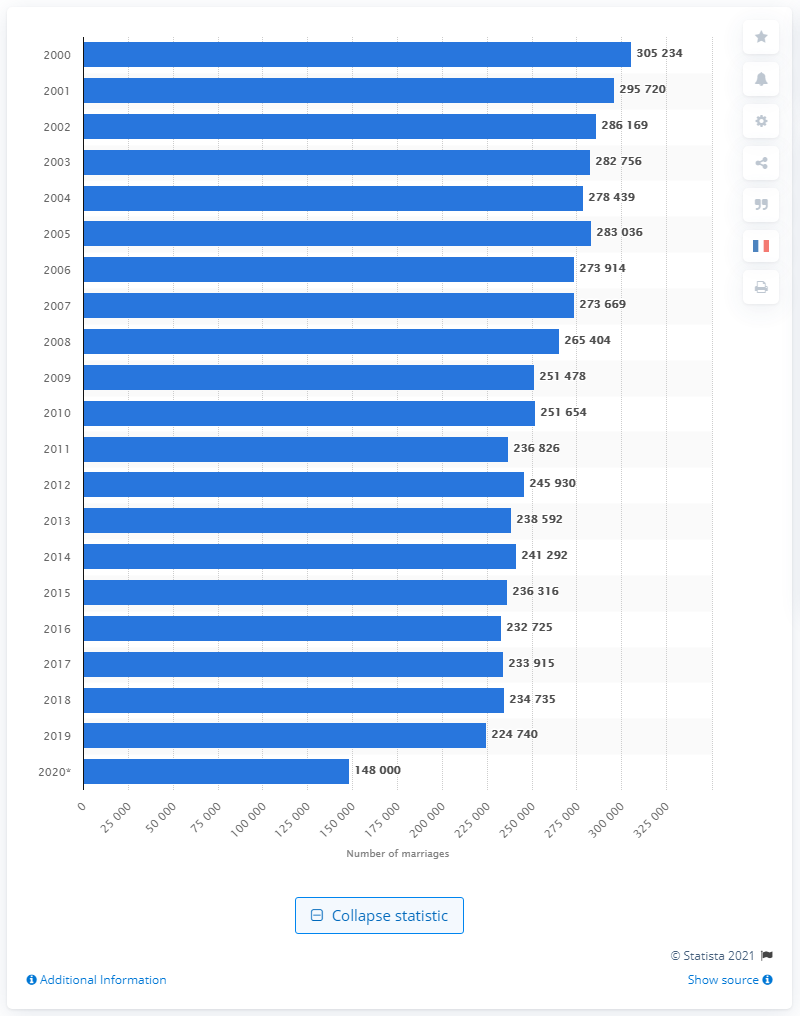Indicate a few pertinent items in this graphic. According to the information provided, France came in second in the number of marriages in Europe in 2014. In 2000, there were 305,234 marriages in France. 